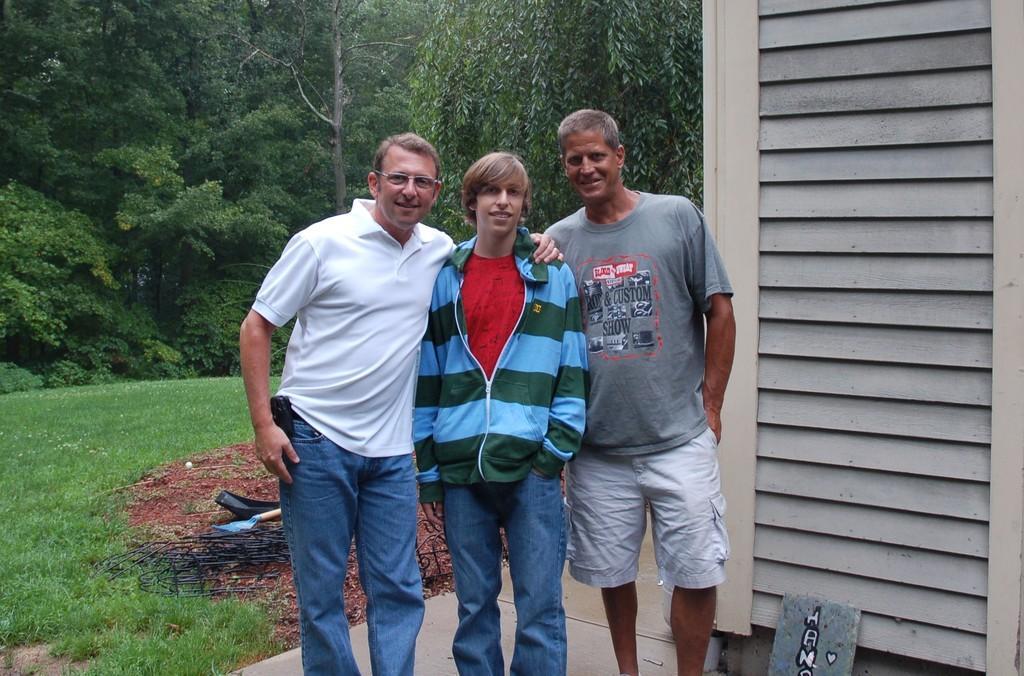How would you summarize this image in a sentence or two? This image consists of three men. In the middle, the man is wearing a jacket. On the left, we can see green grass on the ground. In the background, there are many trees. On the right, it looks like a small cabin. At the bottom, there is a floor. 